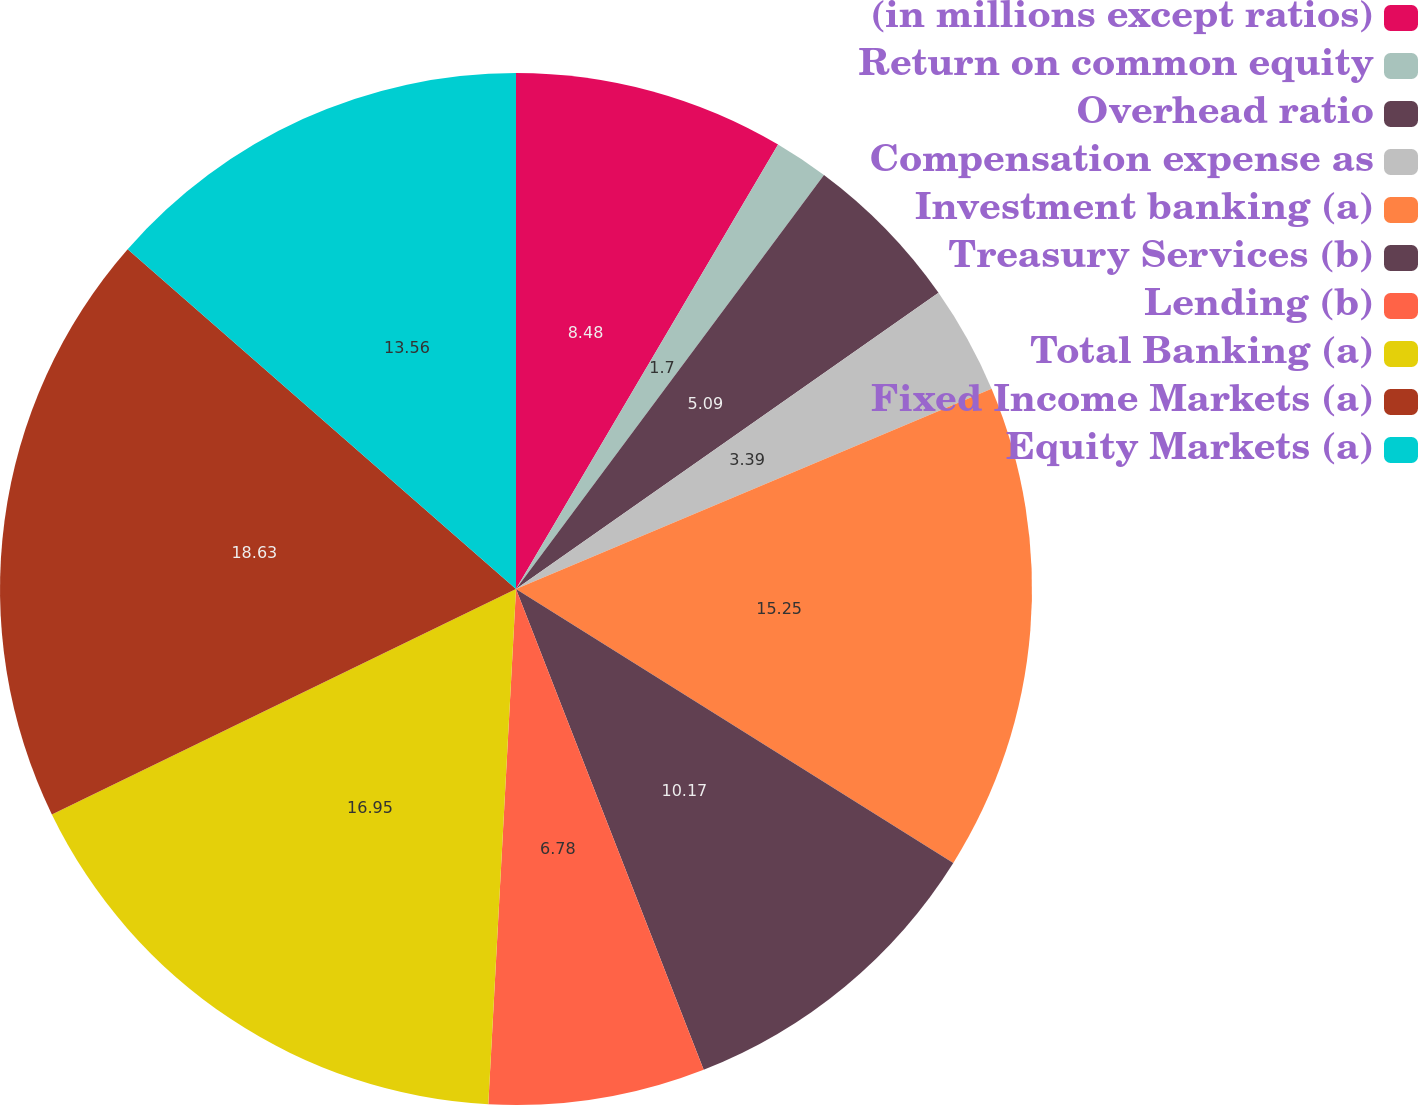Convert chart. <chart><loc_0><loc_0><loc_500><loc_500><pie_chart><fcel>(in millions except ratios)<fcel>Return on common equity<fcel>Overhead ratio<fcel>Compensation expense as<fcel>Investment banking (a)<fcel>Treasury Services (b)<fcel>Lending (b)<fcel>Total Banking (a)<fcel>Fixed Income Markets (a)<fcel>Equity Markets (a)<nl><fcel>8.48%<fcel>1.7%<fcel>5.09%<fcel>3.39%<fcel>15.25%<fcel>10.17%<fcel>6.78%<fcel>16.95%<fcel>18.64%<fcel>13.56%<nl></chart> 